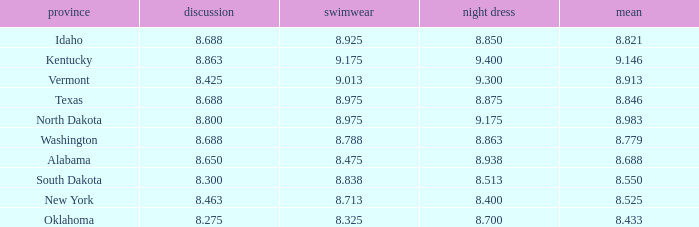What is the highest swimsuit score of the contestant with an evening gown larger than 9.175 and an interview score less than 8.425? None. 